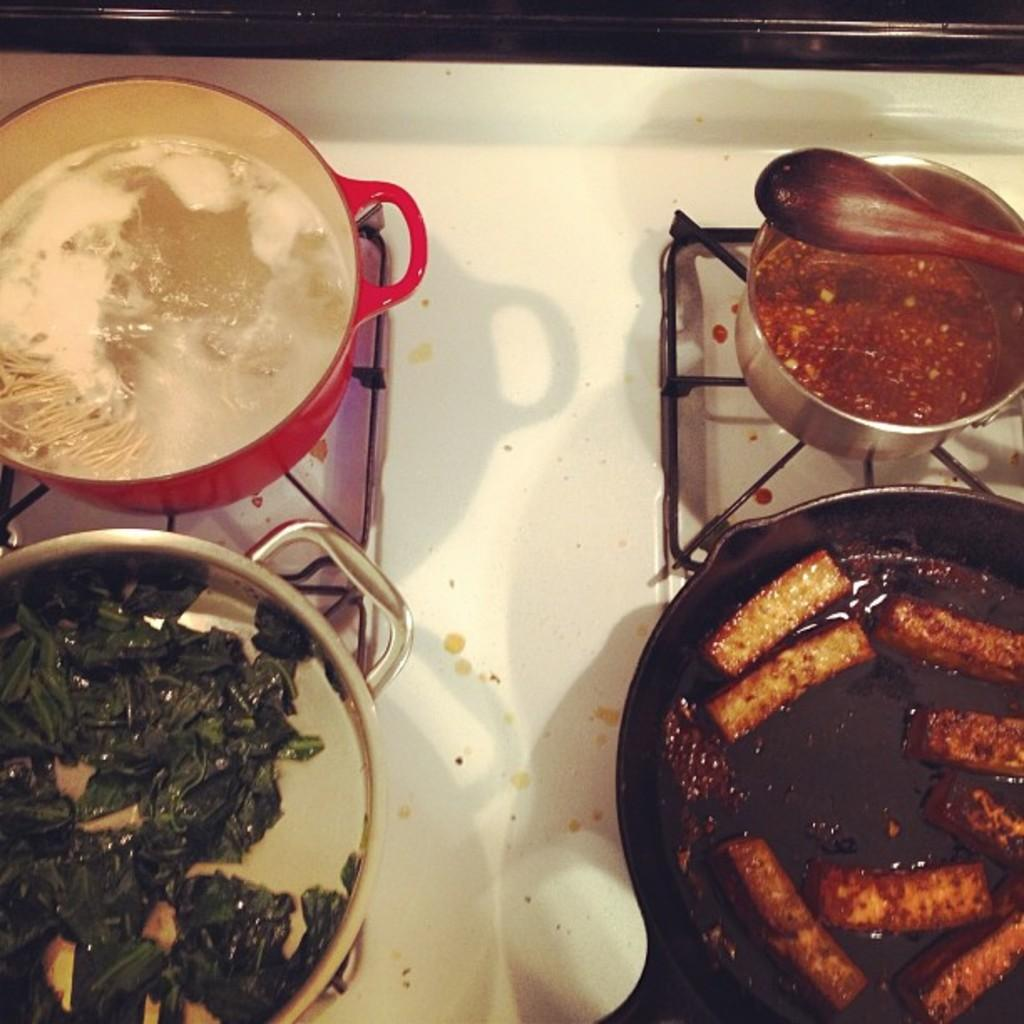What is in the bowls that are visible in the image? There are food items in the bowls. Where are the bowls located in the image? The bowls are placed on a gas stove. What type of flower is being treated in the hospital in the image? There is no flower or hospital present in the image; it features bowls of food on a gas stove. 